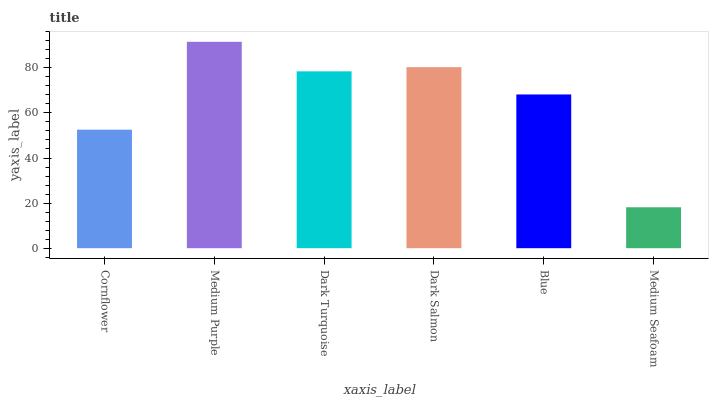Is Medium Seafoam the minimum?
Answer yes or no. Yes. Is Medium Purple the maximum?
Answer yes or no. Yes. Is Dark Turquoise the minimum?
Answer yes or no. No. Is Dark Turquoise the maximum?
Answer yes or no. No. Is Medium Purple greater than Dark Turquoise?
Answer yes or no. Yes. Is Dark Turquoise less than Medium Purple?
Answer yes or no. Yes. Is Dark Turquoise greater than Medium Purple?
Answer yes or no. No. Is Medium Purple less than Dark Turquoise?
Answer yes or no. No. Is Dark Turquoise the high median?
Answer yes or no. Yes. Is Blue the low median?
Answer yes or no. Yes. Is Medium Purple the high median?
Answer yes or no. No. Is Dark Turquoise the low median?
Answer yes or no. No. 